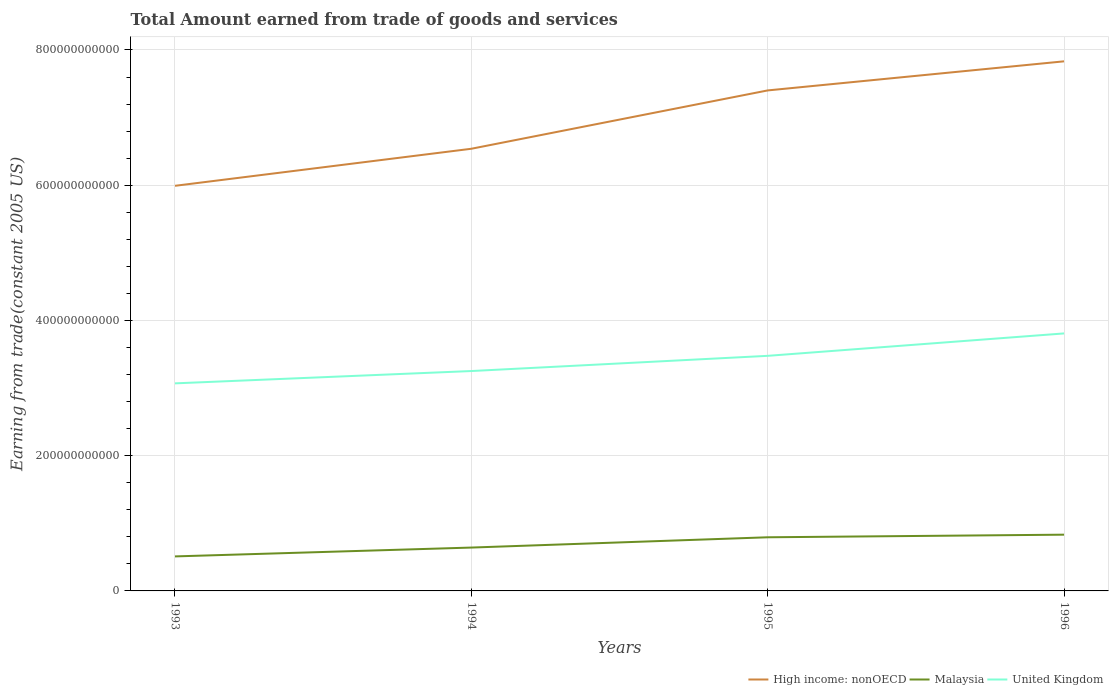How many different coloured lines are there?
Give a very brief answer. 3. Does the line corresponding to High income: nonOECD intersect with the line corresponding to United Kingdom?
Provide a succinct answer. No. Is the number of lines equal to the number of legend labels?
Keep it short and to the point. Yes. Across all years, what is the maximum total amount earned by trading goods and services in United Kingdom?
Your answer should be compact. 3.07e+11. What is the total total amount earned by trading goods and services in High income: nonOECD in the graph?
Offer a very short reply. -1.29e+11. What is the difference between the highest and the second highest total amount earned by trading goods and services in United Kingdom?
Your answer should be very brief. 7.38e+1. What is the difference between the highest and the lowest total amount earned by trading goods and services in Malaysia?
Provide a succinct answer. 2. What is the difference between two consecutive major ticks on the Y-axis?
Offer a terse response. 2.00e+11. Are the values on the major ticks of Y-axis written in scientific E-notation?
Keep it short and to the point. No. How are the legend labels stacked?
Ensure brevity in your answer.  Horizontal. What is the title of the graph?
Provide a succinct answer. Total Amount earned from trade of goods and services. Does "Mauritania" appear as one of the legend labels in the graph?
Offer a terse response. No. What is the label or title of the Y-axis?
Your answer should be compact. Earning from trade(constant 2005 US). What is the Earning from trade(constant 2005 US) in High income: nonOECD in 1993?
Provide a short and direct response. 5.99e+11. What is the Earning from trade(constant 2005 US) in Malaysia in 1993?
Your answer should be very brief. 5.10e+1. What is the Earning from trade(constant 2005 US) of United Kingdom in 1993?
Make the answer very short. 3.07e+11. What is the Earning from trade(constant 2005 US) of High income: nonOECD in 1994?
Your response must be concise. 6.54e+11. What is the Earning from trade(constant 2005 US) of Malaysia in 1994?
Provide a short and direct response. 6.41e+1. What is the Earning from trade(constant 2005 US) of United Kingdom in 1994?
Your response must be concise. 3.25e+11. What is the Earning from trade(constant 2005 US) in High income: nonOECD in 1995?
Your answer should be compact. 7.40e+11. What is the Earning from trade(constant 2005 US) in Malaysia in 1995?
Ensure brevity in your answer.  7.93e+1. What is the Earning from trade(constant 2005 US) in United Kingdom in 1995?
Provide a short and direct response. 3.48e+11. What is the Earning from trade(constant 2005 US) in High income: nonOECD in 1996?
Provide a succinct answer. 7.83e+11. What is the Earning from trade(constant 2005 US) in Malaysia in 1996?
Ensure brevity in your answer.  8.32e+1. What is the Earning from trade(constant 2005 US) of United Kingdom in 1996?
Provide a succinct answer. 3.81e+11. Across all years, what is the maximum Earning from trade(constant 2005 US) in High income: nonOECD?
Keep it short and to the point. 7.83e+11. Across all years, what is the maximum Earning from trade(constant 2005 US) of Malaysia?
Your answer should be compact. 8.32e+1. Across all years, what is the maximum Earning from trade(constant 2005 US) in United Kingdom?
Keep it short and to the point. 3.81e+11. Across all years, what is the minimum Earning from trade(constant 2005 US) of High income: nonOECD?
Provide a succinct answer. 5.99e+11. Across all years, what is the minimum Earning from trade(constant 2005 US) in Malaysia?
Make the answer very short. 5.10e+1. Across all years, what is the minimum Earning from trade(constant 2005 US) of United Kingdom?
Ensure brevity in your answer.  3.07e+11. What is the total Earning from trade(constant 2005 US) of High income: nonOECD in the graph?
Give a very brief answer. 2.78e+12. What is the total Earning from trade(constant 2005 US) of Malaysia in the graph?
Keep it short and to the point. 2.78e+11. What is the total Earning from trade(constant 2005 US) of United Kingdom in the graph?
Offer a very short reply. 1.36e+12. What is the difference between the Earning from trade(constant 2005 US) in High income: nonOECD in 1993 and that in 1994?
Your answer should be very brief. -5.48e+1. What is the difference between the Earning from trade(constant 2005 US) in Malaysia in 1993 and that in 1994?
Keep it short and to the point. -1.31e+1. What is the difference between the Earning from trade(constant 2005 US) of United Kingdom in 1993 and that in 1994?
Make the answer very short. -1.82e+1. What is the difference between the Earning from trade(constant 2005 US) in High income: nonOECD in 1993 and that in 1995?
Provide a succinct answer. -1.41e+11. What is the difference between the Earning from trade(constant 2005 US) in Malaysia in 1993 and that in 1995?
Your answer should be compact. -2.83e+1. What is the difference between the Earning from trade(constant 2005 US) of United Kingdom in 1993 and that in 1995?
Your answer should be compact. -4.07e+1. What is the difference between the Earning from trade(constant 2005 US) of High income: nonOECD in 1993 and that in 1996?
Ensure brevity in your answer.  -1.84e+11. What is the difference between the Earning from trade(constant 2005 US) of Malaysia in 1993 and that in 1996?
Provide a succinct answer. -3.22e+1. What is the difference between the Earning from trade(constant 2005 US) in United Kingdom in 1993 and that in 1996?
Offer a terse response. -7.38e+1. What is the difference between the Earning from trade(constant 2005 US) in High income: nonOECD in 1994 and that in 1995?
Your response must be concise. -8.63e+1. What is the difference between the Earning from trade(constant 2005 US) in Malaysia in 1994 and that in 1995?
Make the answer very short. -1.52e+1. What is the difference between the Earning from trade(constant 2005 US) in United Kingdom in 1994 and that in 1995?
Your answer should be very brief. -2.25e+1. What is the difference between the Earning from trade(constant 2005 US) in High income: nonOECD in 1994 and that in 1996?
Offer a very short reply. -1.29e+11. What is the difference between the Earning from trade(constant 2005 US) of Malaysia in 1994 and that in 1996?
Provide a short and direct response. -1.91e+1. What is the difference between the Earning from trade(constant 2005 US) of United Kingdom in 1994 and that in 1996?
Your answer should be very brief. -5.56e+1. What is the difference between the Earning from trade(constant 2005 US) of High income: nonOECD in 1995 and that in 1996?
Keep it short and to the point. -4.30e+1. What is the difference between the Earning from trade(constant 2005 US) in Malaysia in 1995 and that in 1996?
Your response must be concise. -3.88e+09. What is the difference between the Earning from trade(constant 2005 US) of United Kingdom in 1995 and that in 1996?
Keep it short and to the point. -3.31e+1. What is the difference between the Earning from trade(constant 2005 US) of High income: nonOECD in 1993 and the Earning from trade(constant 2005 US) of Malaysia in 1994?
Offer a terse response. 5.35e+11. What is the difference between the Earning from trade(constant 2005 US) in High income: nonOECD in 1993 and the Earning from trade(constant 2005 US) in United Kingdom in 1994?
Offer a terse response. 2.74e+11. What is the difference between the Earning from trade(constant 2005 US) of Malaysia in 1993 and the Earning from trade(constant 2005 US) of United Kingdom in 1994?
Ensure brevity in your answer.  -2.74e+11. What is the difference between the Earning from trade(constant 2005 US) of High income: nonOECD in 1993 and the Earning from trade(constant 2005 US) of Malaysia in 1995?
Your answer should be compact. 5.20e+11. What is the difference between the Earning from trade(constant 2005 US) in High income: nonOECD in 1993 and the Earning from trade(constant 2005 US) in United Kingdom in 1995?
Provide a succinct answer. 2.51e+11. What is the difference between the Earning from trade(constant 2005 US) in Malaysia in 1993 and the Earning from trade(constant 2005 US) in United Kingdom in 1995?
Offer a terse response. -2.97e+11. What is the difference between the Earning from trade(constant 2005 US) of High income: nonOECD in 1993 and the Earning from trade(constant 2005 US) of Malaysia in 1996?
Provide a short and direct response. 5.16e+11. What is the difference between the Earning from trade(constant 2005 US) of High income: nonOECD in 1993 and the Earning from trade(constant 2005 US) of United Kingdom in 1996?
Give a very brief answer. 2.18e+11. What is the difference between the Earning from trade(constant 2005 US) of Malaysia in 1993 and the Earning from trade(constant 2005 US) of United Kingdom in 1996?
Ensure brevity in your answer.  -3.30e+11. What is the difference between the Earning from trade(constant 2005 US) of High income: nonOECD in 1994 and the Earning from trade(constant 2005 US) of Malaysia in 1995?
Give a very brief answer. 5.75e+11. What is the difference between the Earning from trade(constant 2005 US) of High income: nonOECD in 1994 and the Earning from trade(constant 2005 US) of United Kingdom in 1995?
Make the answer very short. 3.06e+11. What is the difference between the Earning from trade(constant 2005 US) of Malaysia in 1994 and the Earning from trade(constant 2005 US) of United Kingdom in 1995?
Provide a succinct answer. -2.84e+11. What is the difference between the Earning from trade(constant 2005 US) of High income: nonOECD in 1994 and the Earning from trade(constant 2005 US) of Malaysia in 1996?
Provide a succinct answer. 5.71e+11. What is the difference between the Earning from trade(constant 2005 US) in High income: nonOECD in 1994 and the Earning from trade(constant 2005 US) in United Kingdom in 1996?
Provide a short and direct response. 2.73e+11. What is the difference between the Earning from trade(constant 2005 US) in Malaysia in 1994 and the Earning from trade(constant 2005 US) in United Kingdom in 1996?
Offer a very short reply. -3.17e+11. What is the difference between the Earning from trade(constant 2005 US) in High income: nonOECD in 1995 and the Earning from trade(constant 2005 US) in Malaysia in 1996?
Offer a very short reply. 6.57e+11. What is the difference between the Earning from trade(constant 2005 US) in High income: nonOECD in 1995 and the Earning from trade(constant 2005 US) in United Kingdom in 1996?
Offer a very short reply. 3.59e+11. What is the difference between the Earning from trade(constant 2005 US) in Malaysia in 1995 and the Earning from trade(constant 2005 US) in United Kingdom in 1996?
Keep it short and to the point. -3.02e+11. What is the average Earning from trade(constant 2005 US) in High income: nonOECD per year?
Your answer should be very brief. 6.94e+11. What is the average Earning from trade(constant 2005 US) in Malaysia per year?
Provide a succinct answer. 6.94e+1. What is the average Earning from trade(constant 2005 US) in United Kingdom per year?
Offer a terse response. 3.40e+11. In the year 1993, what is the difference between the Earning from trade(constant 2005 US) of High income: nonOECD and Earning from trade(constant 2005 US) of Malaysia?
Give a very brief answer. 5.48e+11. In the year 1993, what is the difference between the Earning from trade(constant 2005 US) in High income: nonOECD and Earning from trade(constant 2005 US) in United Kingdom?
Your answer should be compact. 2.92e+11. In the year 1993, what is the difference between the Earning from trade(constant 2005 US) in Malaysia and Earning from trade(constant 2005 US) in United Kingdom?
Give a very brief answer. -2.56e+11. In the year 1994, what is the difference between the Earning from trade(constant 2005 US) in High income: nonOECD and Earning from trade(constant 2005 US) in Malaysia?
Your response must be concise. 5.90e+11. In the year 1994, what is the difference between the Earning from trade(constant 2005 US) in High income: nonOECD and Earning from trade(constant 2005 US) in United Kingdom?
Your response must be concise. 3.29e+11. In the year 1994, what is the difference between the Earning from trade(constant 2005 US) in Malaysia and Earning from trade(constant 2005 US) in United Kingdom?
Provide a short and direct response. -2.61e+11. In the year 1995, what is the difference between the Earning from trade(constant 2005 US) of High income: nonOECD and Earning from trade(constant 2005 US) of Malaysia?
Keep it short and to the point. 6.61e+11. In the year 1995, what is the difference between the Earning from trade(constant 2005 US) of High income: nonOECD and Earning from trade(constant 2005 US) of United Kingdom?
Ensure brevity in your answer.  3.93e+11. In the year 1995, what is the difference between the Earning from trade(constant 2005 US) of Malaysia and Earning from trade(constant 2005 US) of United Kingdom?
Provide a succinct answer. -2.68e+11. In the year 1996, what is the difference between the Earning from trade(constant 2005 US) in High income: nonOECD and Earning from trade(constant 2005 US) in Malaysia?
Offer a very short reply. 7.00e+11. In the year 1996, what is the difference between the Earning from trade(constant 2005 US) of High income: nonOECD and Earning from trade(constant 2005 US) of United Kingdom?
Keep it short and to the point. 4.02e+11. In the year 1996, what is the difference between the Earning from trade(constant 2005 US) of Malaysia and Earning from trade(constant 2005 US) of United Kingdom?
Make the answer very short. -2.98e+11. What is the ratio of the Earning from trade(constant 2005 US) in High income: nonOECD in 1993 to that in 1994?
Your answer should be very brief. 0.92. What is the ratio of the Earning from trade(constant 2005 US) of Malaysia in 1993 to that in 1994?
Your answer should be very brief. 0.8. What is the ratio of the Earning from trade(constant 2005 US) of United Kingdom in 1993 to that in 1994?
Keep it short and to the point. 0.94. What is the ratio of the Earning from trade(constant 2005 US) in High income: nonOECD in 1993 to that in 1995?
Your answer should be very brief. 0.81. What is the ratio of the Earning from trade(constant 2005 US) in Malaysia in 1993 to that in 1995?
Your answer should be very brief. 0.64. What is the ratio of the Earning from trade(constant 2005 US) in United Kingdom in 1993 to that in 1995?
Provide a succinct answer. 0.88. What is the ratio of the Earning from trade(constant 2005 US) of High income: nonOECD in 1993 to that in 1996?
Offer a very short reply. 0.77. What is the ratio of the Earning from trade(constant 2005 US) in Malaysia in 1993 to that in 1996?
Ensure brevity in your answer.  0.61. What is the ratio of the Earning from trade(constant 2005 US) in United Kingdom in 1993 to that in 1996?
Your response must be concise. 0.81. What is the ratio of the Earning from trade(constant 2005 US) in High income: nonOECD in 1994 to that in 1995?
Provide a short and direct response. 0.88. What is the ratio of the Earning from trade(constant 2005 US) in Malaysia in 1994 to that in 1995?
Keep it short and to the point. 0.81. What is the ratio of the Earning from trade(constant 2005 US) of United Kingdom in 1994 to that in 1995?
Your response must be concise. 0.94. What is the ratio of the Earning from trade(constant 2005 US) in High income: nonOECD in 1994 to that in 1996?
Your answer should be compact. 0.83. What is the ratio of the Earning from trade(constant 2005 US) of Malaysia in 1994 to that in 1996?
Provide a short and direct response. 0.77. What is the ratio of the Earning from trade(constant 2005 US) of United Kingdom in 1994 to that in 1996?
Your response must be concise. 0.85. What is the ratio of the Earning from trade(constant 2005 US) in High income: nonOECD in 1995 to that in 1996?
Offer a terse response. 0.95. What is the ratio of the Earning from trade(constant 2005 US) of Malaysia in 1995 to that in 1996?
Give a very brief answer. 0.95. What is the ratio of the Earning from trade(constant 2005 US) of United Kingdom in 1995 to that in 1996?
Provide a short and direct response. 0.91. What is the difference between the highest and the second highest Earning from trade(constant 2005 US) of High income: nonOECD?
Your answer should be compact. 4.30e+1. What is the difference between the highest and the second highest Earning from trade(constant 2005 US) of Malaysia?
Keep it short and to the point. 3.88e+09. What is the difference between the highest and the second highest Earning from trade(constant 2005 US) in United Kingdom?
Make the answer very short. 3.31e+1. What is the difference between the highest and the lowest Earning from trade(constant 2005 US) of High income: nonOECD?
Offer a terse response. 1.84e+11. What is the difference between the highest and the lowest Earning from trade(constant 2005 US) of Malaysia?
Provide a short and direct response. 3.22e+1. What is the difference between the highest and the lowest Earning from trade(constant 2005 US) of United Kingdom?
Your answer should be compact. 7.38e+1. 